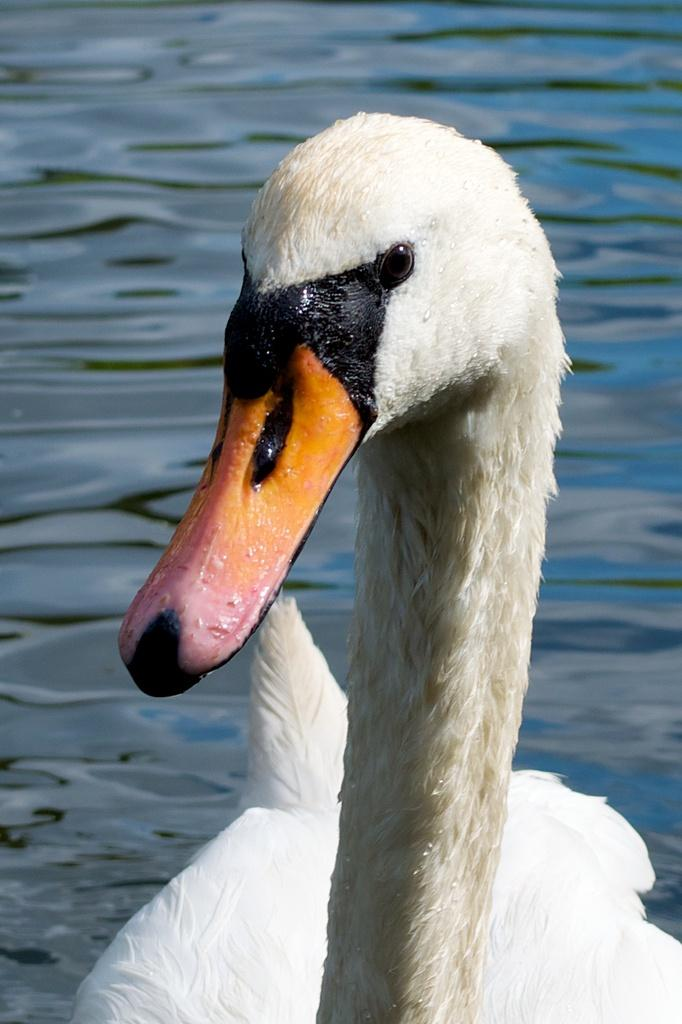What type of animal can be seen in the image? There is a duck in the image. What is the primary element in which the duck is situated? There is water visible in the image, and the duck is in the water. What type of stew is being prepared on the floor in the image? There is no stew or floor present in the image; it features a duck in the water. 